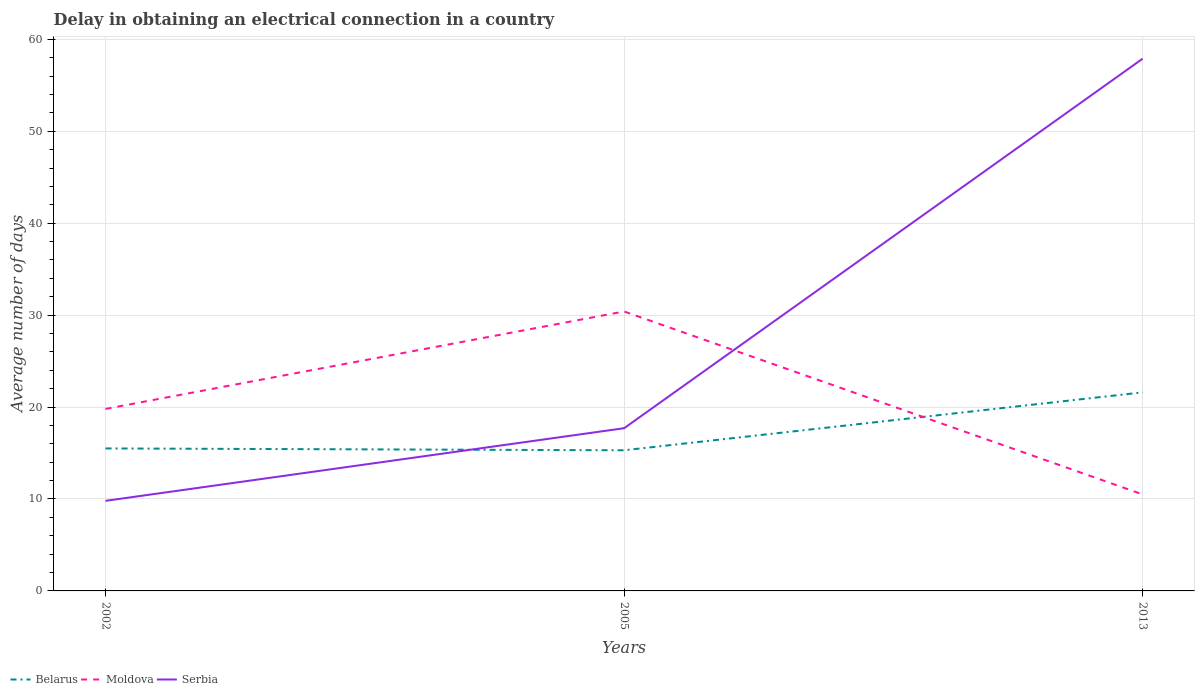How many different coloured lines are there?
Provide a succinct answer. 3. Does the line corresponding to Serbia intersect with the line corresponding to Belarus?
Make the answer very short. Yes. Across all years, what is the maximum average number of days required to obtain an electrical connection in Serbia?
Ensure brevity in your answer.  9.8. What is the total average number of days required to obtain an electrical connection in Belarus in the graph?
Offer a terse response. -6.1. What is the difference between the highest and the second highest average number of days required to obtain an electrical connection in Serbia?
Make the answer very short. 48.1. How many years are there in the graph?
Offer a very short reply. 3. What is the difference between two consecutive major ticks on the Y-axis?
Offer a very short reply. 10. Are the values on the major ticks of Y-axis written in scientific E-notation?
Offer a very short reply. No. Does the graph contain grids?
Give a very brief answer. Yes. Where does the legend appear in the graph?
Keep it short and to the point. Bottom left. How many legend labels are there?
Provide a succinct answer. 3. What is the title of the graph?
Your answer should be very brief. Delay in obtaining an electrical connection in a country. What is the label or title of the Y-axis?
Offer a terse response. Average number of days. What is the Average number of days of Moldova in 2002?
Your response must be concise. 19.8. What is the Average number of days in Moldova in 2005?
Provide a short and direct response. 30.4. What is the Average number of days in Serbia in 2005?
Provide a short and direct response. 17.7. What is the Average number of days in Belarus in 2013?
Ensure brevity in your answer.  21.6. What is the Average number of days in Serbia in 2013?
Your answer should be very brief. 57.9. Across all years, what is the maximum Average number of days of Belarus?
Your answer should be very brief. 21.6. Across all years, what is the maximum Average number of days of Moldova?
Provide a succinct answer. 30.4. Across all years, what is the maximum Average number of days in Serbia?
Provide a succinct answer. 57.9. Across all years, what is the minimum Average number of days of Serbia?
Your answer should be compact. 9.8. What is the total Average number of days in Belarus in the graph?
Your answer should be compact. 52.4. What is the total Average number of days in Moldova in the graph?
Keep it short and to the point. 60.7. What is the total Average number of days in Serbia in the graph?
Your answer should be compact. 85.4. What is the difference between the Average number of days of Belarus in 2002 and that in 2005?
Make the answer very short. 0.2. What is the difference between the Average number of days of Moldova in 2002 and that in 2005?
Make the answer very short. -10.6. What is the difference between the Average number of days in Moldova in 2002 and that in 2013?
Provide a succinct answer. 9.3. What is the difference between the Average number of days of Serbia in 2002 and that in 2013?
Ensure brevity in your answer.  -48.1. What is the difference between the Average number of days in Moldova in 2005 and that in 2013?
Keep it short and to the point. 19.9. What is the difference between the Average number of days of Serbia in 2005 and that in 2013?
Your answer should be compact. -40.2. What is the difference between the Average number of days in Belarus in 2002 and the Average number of days in Moldova in 2005?
Keep it short and to the point. -14.9. What is the difference between the Average number of days of Belarus in 2002 and the Average number of days of Serbia in 2005?
Your answer should be very brief. -2.2. What is the difference between the Average number of days of Moldova in 2002 and the Average number of days of Serbia in 2005?
Make the answer very short. 2.1. What is the difference between the Average number of days of Belarus in 2002 and the Average number of days of Moldova in 2013?
Offer a terse response. 5. What is the difference between the Average number of days in Belarus in 2002 and the Average number of days in Serbia in 2013?
Provide a short and direct response. -42.4. What is the difference between the Average number of days of Moldova in 2002 and the Average number of days of Serbia in 2013?
Your response must be concise. -38.1. What is the difference between the Average number of days of Belarus in 2005 and the Average number of days of Moldova in 2013?
Your response must be concise. 4.8. What is the difference between the Average number of days in Belarus in 2005 and the Average number of days in Serbia in 2013?
Ensure brevity in your answer.  -42.6. What is the difference between the Average number of days in Moldova in 2005 and the Average number of days in Serbia in 2013?
Your answer should be very brief. -27.5. What is the average Average number of days of Belarus per year?
Your response must be concise. 17.47. What is the average Average number of days of Moldova per year?
Ensure brevity in your answer.  20.23. What is the average Average number of days in Serbia per year?
Provide a succinct answer. 28.47. In the year 2002, what is the difference between the Average number of days of Belarus and Average number of days of Serbia?
Offer a terse response. 5.7. In the year 2005, what is the difference between the Average number of days of Belarus and Average number of days of Moldova?
Make the answer very short. -15.1. In the year 2005, what is the difference between the Average number of days in Moldova and Average number of days in Serbia?
Your answer should be very brief. 12.7. In the year 2013, what is the difference between the Average number of days of Belarus and Average number of days of Moldova?
Your answer should be very brief. 11.1. In the year 2013, what is the difference between the Average number of days in Belarus and Average number of days in Serbia?
Make the answer very short. -36.3. In the year 2013, what is the difference between the Average number of days in Moldova and Average number of days in Serbia?
Provide a short and direct response. -47.4. What is the ratio of the Average number of days of Belarus in 2002 to that in 2005?
Offer a very short reply. 1.01. What is the ratio of the Average number of days in Moldova in 2002 to that in 2005?
Keep it short and to the point. 0.65. What is the ratio of the Average number of days in Serbia in 2002 to that in 2005?
Provide a short and direct response. 0.55. What is the ratio of the Average number of days in Belarus in 2002 to that in 2013?
Keep it short and to the point. 0.72. What is the ratio of the Average number of days in Moldova in 2002 to that in 2013?
Your answer should be very brief. 1.89. What is the ratio of the Average number of days in Serbia in 2002 to that in 2013?
Your response must be concise. 0.17. What is the ratio of the Average number of days in Belarus in 2005 to that in 2013?
Keep it short and to the point. 0.71. What is the ratio of the Average number of days of Moldova in 2005 to that in 2013?
Offer a terse response. 2.9. What is the ratio of the Average number of days in Serbia in 2005 to that in 2013?
Your answer should be compact. 0.31. What is the difference between the highest and the second highest Average number of days of Belarus?
Offer a terse response. 6.1. What is the difference between the highest and the second highest Average number of days of Moldova?
Provide a short and direct response. 10.6. What is the difference between the highest and the second highest Average number of days in Serbia?
Your answer should be very brief. 40.2. What is the difference between the highest and the lowest Average number of days in Belarus?
Offer a terse response. 6.3. What is the difference between the highest and the lowest Average number of days of Moldova?
Offer a very short reply. 19.9. What is the difference between the highest and the lowest Average number of days of Serbia?
Make the answer very short. 48.1. 